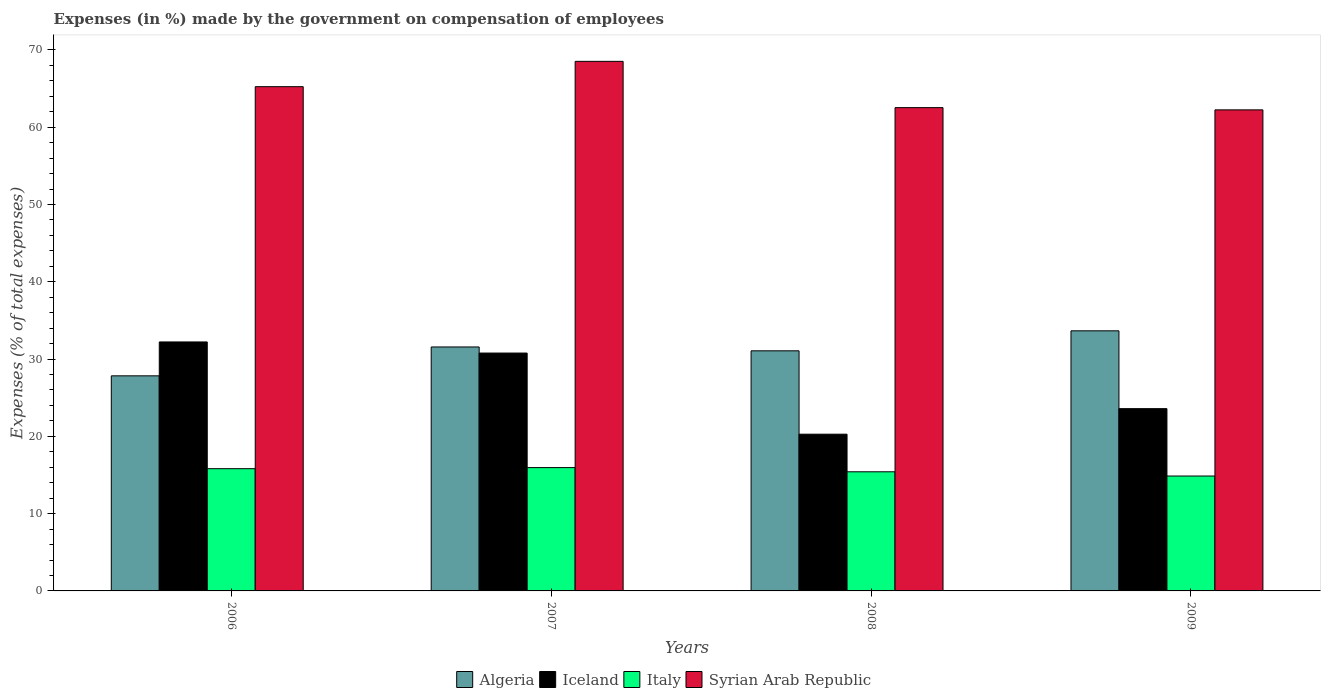Are the number of bars per tick equal to the number of legend labels?
Your answer should be very brief. Yes. Are the number of bars on each tick of the X-axis equal?
Your answer should be compact. Yes. How many bars are there on the 2nd tick from the right?
Offer a terse response. 4. What is the label of the 3rd group of bars from the left?
Keep it short and to the point. 2008. What is the percentage of expenses made by the government on compensation of employees in Algeria in 2008?
Provide a short and direct response. 31.07. Across all years, what is the maximum percentage of expenses made by the government on compensation of employees in Algeria?
Provide a short and direct response. 33.66. Across all years, what is the minimum percentage of expenses made by the government on compensation of employees in Syrian Arab Republic?
Your answer should be very brief. 62.24. In which year was the percentage of expenses made by the government on compensation of employees in Italy maximum?
Your answer should be very brief. 2007. What is the total percentage of expenses made by the government on compensation of employees in Algeria in the graph?
Your answer should be compact. 124.12. What is the difference between the percentage of expenses made by the government on compensation of employees in Syrian Arab Republic in 2006 and that in 2007?
Provide a succinct answer. -3.28. What is the difference between the percentage of expenses made by the government on compensation of employees in Italy in 2009 and the percentage of expenses made by the government on compensation of employees in Algeria in 2006?
Offer a very short reply. -12.96. What is the average percentage of expenses made by the government on compensation of employees in Italy per year?
Offer a very short reply. 15.51. In the year 2009, what is the difference between the percentage of expenses made by the government on compensation of employees in Iceland and percentage of expenses made by the government on compensation of employees in Italy?
Keep it short and to the point. 8.72. In how many years, is the percentage of expenses made by the government on compensation of employees in Algeria greater than 68 %?
Provide a short and direct response. 0. What is the ratio of the percentage of expenses made by the government on compensation of employees in Italy in 2006 to that in 2007?
Offer a very short reply. 0.99. Is the difference between the percentage of expenses made by the government on compensation of employees in Iceland in 2008 and 2009 greater than the difference between the percentage of expenses made by the government on compensation of employees in Italy in 2008 and 2009?
Keep it short and to the point. No. What is the difference between the highest and the second highest percentage of expenses made by the government on compensation of employees in Syrian Arab Republic?
Make the answer very short. 3.28. What is the difference between the highest and the lowest percentage of expenses made by the government on compensation of employees in Italy?
Make the answer very short. 1.09. In how many years, is the percentage of expenses made by the government on compensation of employees in Algeria greater than the average percentage of expenses made by the government on compensation of employees in Algeria taken over all years?
Your response must be concise. 3. What does the 4th bar from the left in 2009 represents?
Offer a very short reply. Syrian Arab Republic. What does the 4th bar from the right in 2009 represents?
Your response must be concise. Algeria. Is it the case that in every year, the sum of the percentage of expenses made by the government on compensation of employees in Algeria and percentage of expenses made by the government on compensation of employees in Syrian Arab Republic is greater than the percentage of expenses made by the government on compensation of employees in Iceland?
Provide a succinct answer. Yes. How many bars are there?
Offer a very short reply. 16. Are all the bars in the graph horizontal?
Make the answer very short. No. Are the values on the major ticks of Y-axis written in scientific E-notation?
Your response must be concise. No. Does the graph contain grids?
Offer a very short reply. No. Where does the legend appear in the graph?
Your response must be concise. Bottom center. How are the legend labels stacked?
Ensure brevity in your answer.  Horizontal. What is the title of the graph?
Keep it short and to the point. Expenses (in %) made by the government on compensation of employees. What is the label or title of the Y-axis?
Offer a very short reply. Expenses (% of total expenses). What is the Expenses (% of total expenses) in Algeria in 2006?
Your response must be concise. 27.83. What is the Expenses (% of total expenses) in Iceland in 2006?
Your response must be concise. 32.21. What is the Expenses (% of total expenses) in Italy in 2006?
Provide a succinct answer. 15.82. What is the Expenses (% of total expenses) in Syrian Arab Republic in 2006?
Provide a succinct answer. 65.25. What is the Expenses (% of total expenses) in Algeria in 2007?
Provide a succinct answer. 31.57. What is the Expenses (% of total expenses) in Iceland in 2007?
Offer a very short reply. 30.78. What is the Expenses (% of total expenses) in Italy in 2007?
Your response must be concise. 15.96. What is the Expenses (% of total expenses) in Syrian Arab Republic in 2007?
Provide a succinct answer. 68.52. What is the Expenses (% of total expenses) in Algeria in 2008?
Keep it short and to the point. 31.07. What is the Expenses (% of total expenses) in Iceland in 2008?
Your answer should be compact. 20.28. What is the Expenses (% of total expenses) of Italy in 2008?
Offer a terse response. 15.42. What is the Expenses (% of total expenses) in Syrian Arab Republic in 2008?
Your response must be concise. 62.53. What is the Expenses (% of total expenses) of Algeria in 2009?
Your answer should be very brief. 33.66. What is the Expenses (% of total expenses) in Iceland in 2009?
Your answer should be very brief. 23.58. What is the Expenses (% of total expenses) in Italy in 2009?
Your answer should be very brief. 14.87. What is the Expenses (% of total expenses) of Syrian Arab Republic in 2009?
Offer a very short reply. 62.24. Across all years, what is the maximum Expenses (% of total expenses) of Algeria?
Keep it short and to the point. 33.66. Across all years, what is the maximum Expenses (% of total expenses) in Iceland?
Give a very brief answer. 32.21. Across all years, what is the maximum Expenses (% of total expenses) in Italy?
Provide a succinct answer. 15.96. Across all years, what is the maximum Expenses (% of total expenses) of Syrian Arab Republic?
Provide a short and direct response. 68.52. Across all years, what is the minimum Expenses (% of total expenses) of Algeria?
Your answer should be very brief. 27.83. Across all years, what is the minimum Expenses (% of total expenses) of Iceland?
Your response must be concise. 20.28. Across all years, what is the minimum Expenses (% of total expenses) in Italy?
Provide a succinct answer. 14.87. Across all years, what is the minimum Expenses (% of total expenses) in Syrian Arab Republic?
Offer a very short reply. 62.24. What is the total Expenses (% of total expenses) in Algeria in the graph?
Keep it short and to the point. 124.12. What is the total Expenses (% of total expenses) in Iceland in the graph?
Provide a succinct answer. 106.86. What is the total Expenses (% of total expenses) of Italy in the graph?
Your answer should be compact. 62.06. What is the total Expenses (% of total expenses) of Syrian Arab Republic in the graph?
Offer a very short reply. 258.55. What is the difference between the Expenses (% of total expenses) in Algeria in 2006 and that in 2007?
Make the answer very short. -3.74. What is the difference between the Expenses (% of total expenses) in Iceland in 2006 and that in 2007?
Your answer should be compact. 1.44. What is the difference between the Expenses (% of total expenses) of Italy in 2006 and that in 2007?
Your response must be concise. -0.14. What is the difference between the Expenses (% of total expenses) of Syrian Arab Republic in 2006 and that in 2007?
Provide a short and direct response. -3.28. What is the difference between the Expenses (% of total expenses) of Algeria in 2006 and that in 2008?
Ensure brevity in your answer.  -3.24. What is the difference between the Expenses (% of total expenses) in Iceland in 2006 and that in 2008?
Provide a succinct answer. 11.94. What is the difference between the Expenses (% of total expenses) in Italy in 2006 and that in 2008?
Your answer should be very brief. 0.4. What is the difference between the Expenses (% of total expenses) in Syrian Arab Republic in 2006 and that in 2008?
Give a very brief answer. 2.71. What is the difference between the Expenses (% of total expenses) of Algeria in 2006 and that in 2009?
Provide a succinct answer. -5.83. What is the difference between the Expenses (% of total expenses) in Iceland in 2006 and that in 2009?
Offer a terse response. 8.63. What is the difference between the Expenses (% of total expenses) in Italy in 2006 and that in 2009?
Provide a short and direct response. 0.95. What is the difference between the Expenses (% of total expenses) in Syrian Arab Republic in 2006 and that in 2009?
Offer a very short reply. 3. What is the difference between the Expenses (% of total expenses) in Algeria in 2007 and that in 2008?
Make the answer very short. 0.5. What is the difference between the Expenses (% of total expenses) of Iceland in 2007 and that in 2008?
Your answer should be compact. 10.5. What is the difference between the Expenses (% of total expenses) in Italy in 2007 and that in 2008?
Your response must be concise. 0.54. What is the difference between the Expenses (% of total expenses) of Syrian Arab Republic in 2007 and that in 2008?
Your answer should be very brief. 5.99. What is the difference between the Expenses (% of total expenses) in Algeria in 2007 and that in 2009?
Make the answer very short. -2.09. What is the difference between the Expenses (% of total expenses) of Iceland in 2007 and that in 2009?
Give a very brief answer. 7.19. What is the difference between the Expenses (% of total expenses) of Italy in 2007 and that in 2009?
Provide a short and direct response. 1.09. What is the difference between the Expenses (% of total expenses) of Syrian Arab Republic in 2007 and that in 2009?
Give a very brief answer. 6.28. What is the difference between the Expenses (% of total expenses) in Algeria in 2008 and that in 2009?
Offer a very short reply. -2.59. What is the difference between the Expenses (% of total expenses) of Iceland in 2008 and that in 2009?
Make the answer very short. -3.31. What is the difference between the Expenses (% of total expenses) of Italy in 2008 and that in 2009?
Ensure brevity in your answer.  0.55. What is the difference between the Expenses (% of total expenses) in Syrian Arab Republic in 2008 and that in 2009?
Your response must be concise. 0.29. What is the difference between the Expenses (% of total expenses) of Algeria in 2006 and the Expenses (% of total expenses) of Iceland in 2007?
Offer a terse response. -2.95. What is the difference between the Expenses (% of total expenses) of Algeria in 2006 and the Expenses (% of total expenses) of Italy in 2007?
Your answer should be compact. 11.87. What is the difference between the Expenses (% of total expenses) of Algeria in 2006 and the Expenses (% of total expenses) of Syrian Arab Republic in 2007?
Give a very brief answer. -40.69. What is the difference between the Expenses (% of total expenses) in Iceland in 2006 and the Expenses (% of total expenses) in Italy in 2007?
Ensure brevity in your answer.  16.26. What is the difference between the Expenses (% of total expenses) in Iceland in 2006 and the Expenses (% of total expenses) in Syrian Arab Republic in 2007?
Offer a terse response. -36.31. What is the difference between the Expenses (% of total expenses) of Italy in 2006 and the Expenses (% of total expenses) of Syrian Arab Republic in 2007?
Make the answer very short. -52.71. What is the difference between the Expenses (% of total expenses) of Algeria in 2006 and the Expenses (% of total expenses) of Iceland in 2008?
Your response must be concise. 7.55. What is the difference between the Expenses (% of total expenses) in Algeria in 2006 and the Expenses (% of total expenses) in Italy in 2008?
Offer a terse response. 12.41. What is the difference between the Expenses (% of total expenses) in Algeria in 2006 and the Expenses (% of total expenses) in Syrian Arab Republic in 2008?
Your answer should be compact. -34.7. What is the difference between the Expenses (% of total expenses) in Iceland in 2006 and the Expenses (% of total expenses) in Italy in 2008?
Your answer should be compact. 16.8. What is the difference between the Expenses (% of total expenses) in Iceland in 2006 and the Expenses (% of total expenses) in Syrian Arab Republic in 2008?
Your response must be concise. -30.32. What is the difference between the Expenses (% of total expenses) of Italy in 2006 and the Expenses (% of total expenses) of Syrian Arab Republic in 2008?
Make the answer very short. -46.72. What is the difference between the Expenses (% of total expenses) in Algeria in 2006 and the Expenses (% of total expenses) in Iceland in 2009?
Ensure brevity in your answer.  4.25. What is the difference between the Expenses (% of total expenses) of Algeria in 2006 and the Expenses (% of total expenses) of Italy in 2009?
Provide a succinct answer. 12.96. What is the difference between the Expenses (% of total expenses) of Algeria in 2006 and the Expenses (% of total expenses) of Syrian Arab Republic in 2009?
Offer a very short reply. -34.41. What is the difference between the Expenses (% of total expenses) in Iceland in 2006 and the Expenses (% of total expenses) in Italy in 2009?
Your answer should be very brief. 17.35. What is the difference between the Expenses (% of total expenses) in Iceland in 2006 and the Expenses (% of total expenses) in Syrian Arab Republic in 2009?
Provide a succinct answer. -30.03. What is the difference between the Expenses (% of total expenses) in Italy in 2006 and the Expenses (% of total expenses) in Syrian Arab Republic in 2009?
Your answer should be very brief. -46.43. What is the difference between the Expenses (% of total expenses) in Algeria in 2007 and the Expenses (% of total expenses) in Iceland in 2008?
Offer a terse response. 11.29. What is the difference between the Expenses (% of total expenses) of Algeria in 2007 and the Expenses (% of total expenses) of Italy in 2008?
Ensure brevity in your answer.  16.15. What is the difference between the Expenses (% of total expenses) of Algeria in 2007 and the Expenses (% of total expenses) of Syrian Arab Republic in 2008?
Your answer should be compact. -30.97. What is the difference between the Expenses (% of total expenses) of Iceland in 2007 and the Expenses (% of total expenses) of Italy in 2008?
Ensure brevity in your answer.  15.36. What is the difference between the Expenses (% of total expenses) of Iceland in 2007 and the Expenses (% of total expenses) of Syrian Arab Republic in 2008?
Keep it short and to the point. -31.76. What is the difference between the Expenses (% of total expenses) in Italy in 2007 and the Expenses (% of total expenses) in Syrian Arab Republic in 2008?
Your answer should be compact. -46.58. What is the difference between the Expenses (% of total expenses) of Algeria in 2007 and the Expenses (% of total expenses) of Iceland in 2009?
Offer a terse response. 7.98. What is the difference between the Expenses (% of total expenses) of Algeria in 2007 and the Expenses (% of total expenses) of Italy in 2009?
Make the answer very short. 16.7. What is the difference between the Expenses (% of total expenses) in Algeria in 2007 and the Expenses (% of total expenses) in Syrian Arab Republic in 2009?
Offer a terse response. -30.68. What is the difference between the Expenses (% of total expenses) in Iceland in 2007 and the Expenses (% of total expenses) in Italy in 2009?
Make the answer very short. 15.91. What is the difference between the Expenses (% of total expenses) in Iceland in 2007 and the Expenses (% of total expenses) in Syrian Arab Republic in 2009?
Your answer should be very brief. -31.47. What is the difference between the Expenses (% of total expenses) in Italy in 2007 and the Expenses (% of total expenses) in Syrian Arab Republic in 2009?
Your answer should be very brief. -46.29. What is the difference between the Expenses (% of total expenses) of Algeria in 2008 and the Expenses (% of total expenses) of Iceland in 2009?
Provide a short and direct response. 7.48. What is the difference between the Expenses (% of total expenses) in Algeria in 2008 and the Expenses (% of total expenses) in Italy in 2009?
Your answer should be compact. 16.2. What is the difference between the Expenses (% of total expenses) in Algeria in 2008 and the Expenses (% of total expenses) in Syrian Arab Republic in 2009?
Offer a terse response. -31.18. What is the difference between the Expenses (% of total expenses) of Iceland in 2008 and the Expenses (% of total expenses) of Italy in 2009?
Offer a terse response. 5.41. What is the difference between the Expenses (% of total expenses) of Iceland in 2008 and the Expenses (% of total expenses) of Syrian Arab Republic in 2009?
Ensure brevity in your answer.  -41.97. What is the difference between the Expenses (% of total expenses) of Italy in 2008 and the Expenses (% of total expenses) of Syrian Arab Republic in 2009?
Provide a short and direct response. -46.83. What is the average Expenses (% of total expenses) in Algeria per year?
Keep it short and to the point. 31.03. What is the average Expenses (% of total expenses) of Iceland per year?
Provide a succinct answer. 26.71. What is the average Expenses (% of total expenses) in Italy per year?
Offer a terse response. 15.51. What is the average Expenses (% of total expenses) of Syrian Arab Republic per year?
Your response must be concise. 64.64. In the year 2006, what is the difference between the Expenses (% of total expenses) in Algeria and Expenses (% of total expenses) in Iceland?
Your answer should be very brief. -4.38. In the year 2006, what is the difference between the Expenses (% of total expenses) in Algeria and Expenses (% of total expenses) in Italy?
Your answer should be compact. 12.01. In the year 2006, what is the difference between the Expenses (% of total expenses) in Algeria and Expenses (% of total expenses) in Syrian Arab Republic?
Offer a very short reply. -37.41. In the year 2006, what is the difference between the Expenses (% of total expenses) in Iceland and Expenses (% of total expenses) in Italy?
Make the answer very short. 16.4. In the year 2006, what is the difference between the Expenses (% of total expenses) in Iceland and Expenses (% of total expenses) in Syrian Arab Republic?
Keep it short and to the point. -33.03. In the year 2006, what is the difference between the Expenses (% of total expenses) in Italy and Expenses (% of total expenses) in Syrian Arab Republic?
Offer a terse response. -49.43. In the year 2007, what is the difference between the Expenses (% of total expenses) in Algeria and Expenses (% of total expenses) in Iceland?
Provide a short and direct response. 0.79. In the year 2007, what is the difference between the Expenses (% of total expenses) in Algeria and Expenses (% of total expenses) in Italy?
Offer a very short reply. 15.61. In the year 2007, what is the difference between the Expenses (% of total expenses) of Algeria and Expenses (% of total expenses) of Syrian Arab Republic?
Provide a succinct answer. -36.95. In the year 2007, what is the difference between the Expenses (% of total expenses) of Iceland and Expenses (% of total expenses) of Italy?
Keep it short and to the point. 14.82. In the year 2007, what is the difference between the Expenses (% of total expenses) in Iceland and Expenses (% of total expenses) in Syrian Arab Republic?
Ensure brevity in your answer.  -37.74. In the year 2007, what is the difference between the Expenses (% of total expenses) of Italy and Expenses (% of total expenses) of Syrian Arab Republic?
Give a very brief answer. -52.56. In the year 2008, what is the difference between the Expenses (% of total expenses) in Algeria and Expenses (% of total expenses) in Iceland?
Provide a succinct answer. 10.79. In the year 2008, what is the difference between the Expenses (% of total expenses) in Algeria and Expenses (% of total expenses) in Italy?
Your answer should be compact. 15.65. In the year 2008, what is the difference between the Expenses (% of total expenses) in Algeria and Expenses (% of total expenses) in Syrian Arab Republic?
Keep it short and to the point. -31.47. In the year 2008, what is the difference between the Expenses (% of total expenses) of Iceland and Expenses (% of total expenses) of Italy?
Your response must be concise. 4.86. In the year 2008, what is the difference between the Expenses (% of total expenses) in Iceland and Expenses (% of total expenses) in Syrian Arab Republic?
Keep it short and to the point. -42.26. In the year 2008, what is the difference between the Expenses (% of total expenses) of Italy and Expenses (% of total expenses) of Syrian Arab Republic?
Provide a succinct answer. -47.12. In the year 2009, what is the difference between the Expenses (% of total expenses) in Algeria and Expenses (% of total expenses) in Iceland?
Your answer should be very brief. 10.07. In the year 2009, what is the difference between the Expenses (% of total expenses) in Algeria and Expenses (% of total expenses) in Italy?
Provide a succinct answer. 18.79. In the year 2009, what is the difference between the Expenses (% of total expenses) in Algeria and Expenses (% of total expenses) in Syrian Arab Republic?
Your response must be concise. -28.59. In the year 2009, what is the difference between the Expenses (% of total expenses) in Iceland and Expenses (% of total expenses) in Italy?
Provide a short and direct response. 8.72. In the year 2009, what is the difference between the Expenses (% of total expenses) in Iceland and Expenses (% of total expenses) in Syrian Arab Republic?
Offer a very short reply. -38.66. In the year 2009, what is the difference between the Expenses (% of total expenses) of Italy and Expenses (% of total expenses) of Syrian Arab Republic?
Ensure brevity in your answer.  -47.38. What is the ratio of the Expenses (% of total expenses) of Algeria in 2006 to that in 2007?
Make the answer very short. 0.88. What is the ratio of the Expenses (% of total expenses) in Iceland in 2006 to that in 2007?
Ensure brevity in your answer.  1.05. What is the ratio of the Expenses (% of total expenses) in Syrian Arab Republic in 2006 to that in 2007?
Offer a very short reply. 0.95. What is the ratio of the Expenses (% of total expenses) in Algeria in 2006 to that in 2008?
Provide a short and direct response. 0.9. What is the ratio of the Expenses (% of total expenses) of Iceland in 2006 to that in 2008?
Your answer should be compact. 1.59. What is the ratio of the Expenses (% of total expenses) in Italy in 2006 to that in 2008?
Keep it short and to the point. 1.03. What is the ratio of the Expenses (% of total expenses) in Syrian Arab Republic in 2006 to that in 2008?
Provide a short and direct response. 1.04. What is the ratio of the Expenses (% of total expenses) in Algeria in 2006 to that in 2009?
Give a very brief answer. 0.83. What is the ratio of the Expenses (% of total expenses) of Iceland in 2006 to that in 2009?
Your answer should be very brief. 1.37. What is the ratio of the Expenses (% of total expenses) in Italy in 2006 to that in 2009?
Your answer should be very brief. 1.06. What is the ratio of the Expenses (% of total expenses) in Syrian Arab Republic in 2006 to that in 2009?
Provide a short and direct response. 1.05. What is the ratio of the Expenses (% of total expenses) of Algeria in 2007 to that in 2008?
Provide a short and direct response. 1.02. What is the ratio of the Expenses (% of total expenses) of Iceland in 2007 to that in 2008?
Your answer should be very brief. 1.52. What is the ratio of the Expenses (% of total expenses) of Italy in 2007 to that in 2008?
Make the answer very short. 1.04. What is the ratio of the Expenses (% of total expenses) of Syrian Arab Republic in 2007 to that in 2008?
Give a very brief answer. 1.1. What is the ratio of the Expenses (% of total expenses) of Algeria in 2007 to that in 2009?
Your answer should be very brief. 0.94. What is the ratio of the Expenses (% of total expenses) in Iceland in 2007 to that in 2009?
Your answer should be very brief. 1.3. What is the ratio of the Expenses (% of total expenses) in Italy in 2007 to that in 2009?
Your response must be concise. 1.07. What is the ratio of the Expenses (% of total expenses) of Syrian Arab Republic in 2007 to that in 2009?
Keep it short and to the point. 1.1. What is the ratio of the Expenses (% of total expenses) of Iceland in 2008 to that in 2009?
Offer a very short reply. 0.86. What is the ratio of the Expenses (% of total expenses) of Italy in 2008 to that in 2009?
Your response must be concise. 1.04. What is the difference between the highest and the second highest Expenses (% of total expenses) of Algeria?
Your answer should be very brief. 2.09. What is the difference between the highest and the second highest Expenses (% of total expenses) of Iceland?
Provide a succinct answer. 1.44. What is the difference between the highest and the second highest Expenses (% of total expenses) of Italy?
Your answer should be very brief. 0.14. What is the difference between the highest and the second highest Expenses (% of total expenses) in Syrian Arab Republic?
Offer a terse response. 3.28. What is the difference between the highest and the lowest Expenses (% of total expenses) of Algeria?
Keep it short and to the point. 5.83. What is the difference between the highest and the lowest Expenses (% of total expenses) of Iceland?
Give a very brief answer. 11.94. What is the difference between the highest and the lowest Expenses (% of total expenses) in Italy?
Your answer should be very brief. 1.09. What is the difference between the highest and the lowest Expenses (% of total expenses) of Syrian Arab Republic?
Provide a succinct answer. 6.28. 